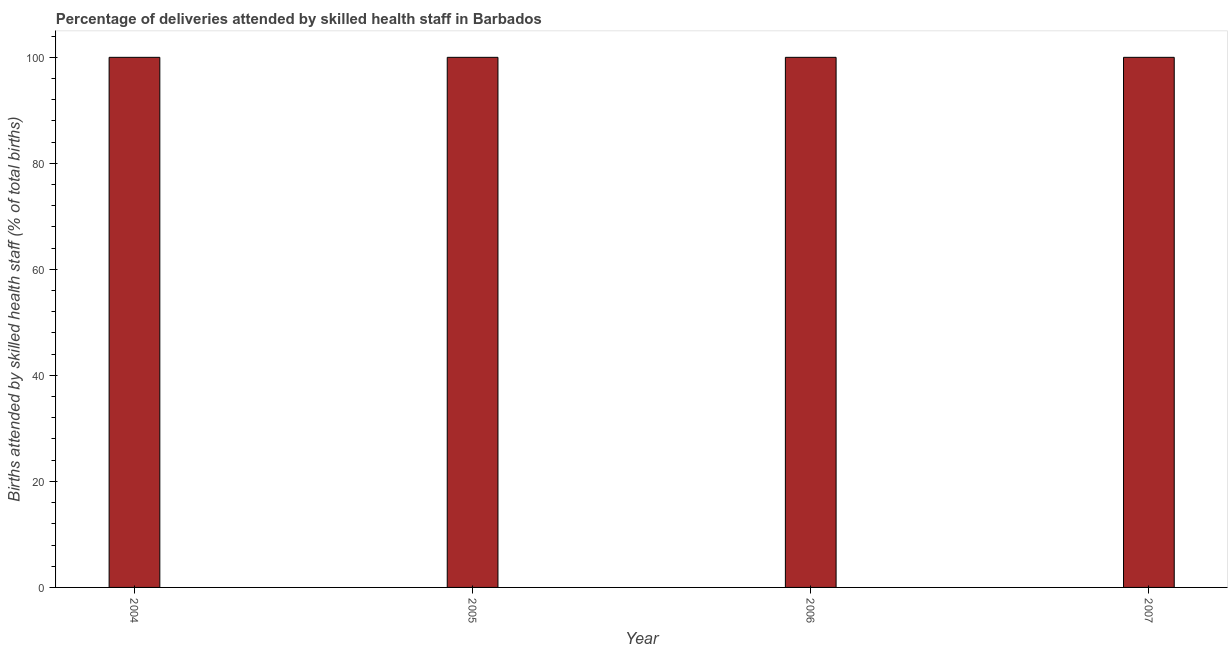What is the title of the graph?
Offer a very short reply. Percentage of deliveries attended by skilled health staff in Barbados. What is the label or title of the Y-axis?
Offer a very short reply. Births attended by skilled health staff (% of total births). What is the number of births attended by skilled health staff in 2006?
Give a very brief answer. 100. Across all years, what is the minimum number of births attended by skilled health staff?
Provide a short and direct response. 100. In which year was the number of births attended by skilled health staff maximum?
Ensure brevity in your answer.  2004. What is the sum of the number of births attended by skilled health staff?
Offer a terse response. 400. What is the average number of births attended by skilled health staff per year?
Provide a succinct answer. 100. What is the median number of births attended by skilled health staff?
Ensure brevity in your answer.  100. Is the number of births attended by skilled health staff in 2004 less than that in 2005?
Keep it short and to the point. No. Is the sum of the number of births attended by skilled health staff in 2004 and 2005 greater than the maximum number of births attended by skilled health staff across all years?
Offer a terse response. Yes. What is the difference between the highest and the lowest number of births attended by skilled health staff?
Your response must be concise. 0. In how many years, is the number of births attended by skilled health staff greater than the average number of births attended by skilled health staff taken over all years?
Provide a succinct answer. 0. How many bars are there?
Keep it short and to the point. 4. Are all the bars in the graph horizontal?
Your response must be concise. No. How many years are there in the graph?
Keep it short and to the point. 4. What is the difference between two consecutive major ticks on the Y-axis?
Provide a succinct answer. 20. Are the values on the major ticks of Y-axis written in scientific E-notation?
Make the answer very short. No. What is the Births attended by skilled health staff (% of total births) of 2004?
Your response must be concise. 100. What is the Births attended by skilled health staff (% of total births) in 2005?
Offer a terse response. 100. What is the difference between the Births attended by skilled health staff (% of total births) in 2004 and 2006?
Your response must be concise. 0. What is the difference between the Births attended by skilled health staff (% of total births) in 2005 and 2006?
Give a very brief answer. 0. What is the difference between the Births attended by skilled health staff (% of total births) in 2005 and 2007?
Your answer should be very brief. 0. What is the ratio of the Births attended by skilled health staff (% of total births) in 2004 to that in 2007?
Provide a short and direct response. 1. 